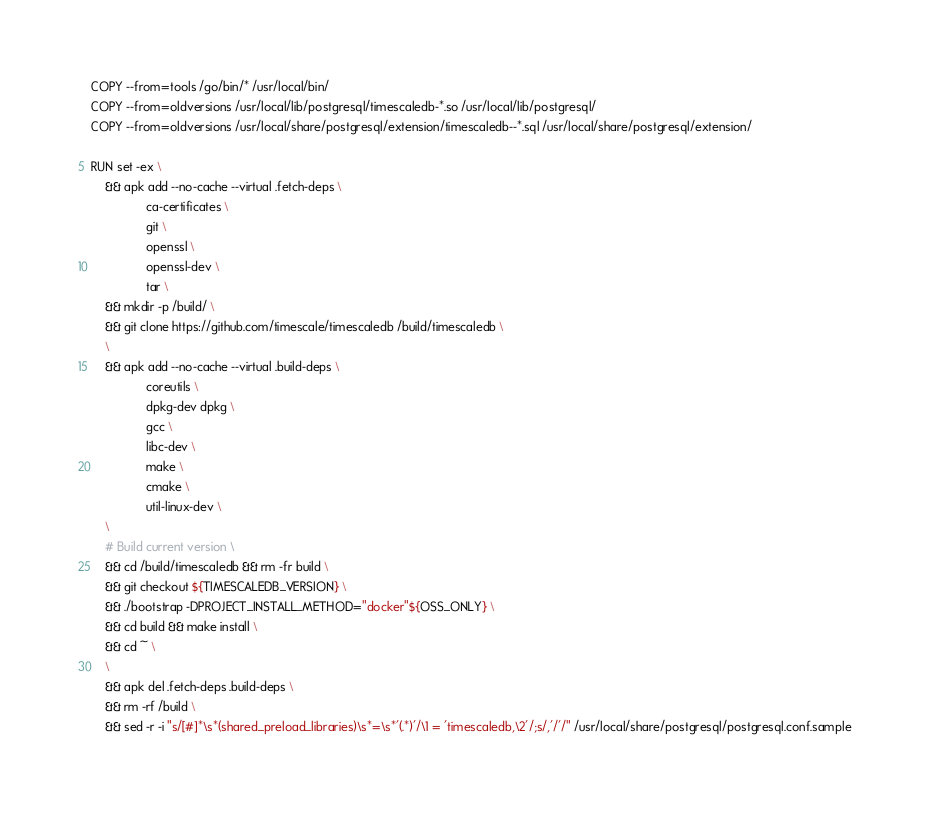Convert code to text. <code><loc_0><loc_0><loc_500><loc_500><_Dockerfile_>COPY --from=tools /go/bin/* /usr/local/bin/
COPY --from=oldversions /usr/local/lib/postgresql/timescaledb-*.so /usr/local/lib/postgresql/
COPY --from=oldversions /usr/local/share/postgresql/extension/timescaledb--*.sql /usr/local/share/postgresql/extension/

RUN set -ex \
    && apk add --no-cache --virtual .fetch-deps \
                ca-certificates \
                git \
                openssl \
                openssl-dev \
                tar \
    && mkdir -p /build/ \
    && git clone https://github.com/timescale/timescaledb /build/timescaledb \
    \
    && apk add --no-cache --virtual .build-deps \
                coreutils \
                dpkg-dev dpkg \
                gcc \
                libc-dev \
                make \
                cmake \
                util-linux-dev \
    \
    # Build current version \
    && cd /build/timescaledb && rm -fr build \
    && git checkout ${TIMESCALEDB_VERSION} \
    && ./bootstrap -DPROJECT_INSTALL_METHOD="docker"${OSS_ONLY} \
    && cd build && make install \
    && cd ~ \
    \
    && apk del .fetch-deps .build-deps \
    && rm -rf /build \
    && sed -r -i "s/[#]*\s*(shared_preload_libraries)\s*=\s*'(.*)'/\1 = 'timescaledb,\2'/;s/,'/'/" /usr/local/share/postgresql/postgresql.conf.sample
</code> 